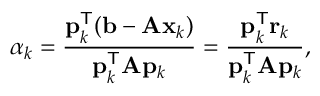<formula> <loc_0><loc_0><loc_500><loc_500>\alpha _ { k } = { \frac { p _ { k } ^ { T } ( b - A x _ { k } ) } { p _ { k } ^ { T } A p _ { k } } } = { \frac { p _ { k } ^ { T } r _ { k } } { p _ { k } ^ { T } A p _ { k } } } ,</formula> 